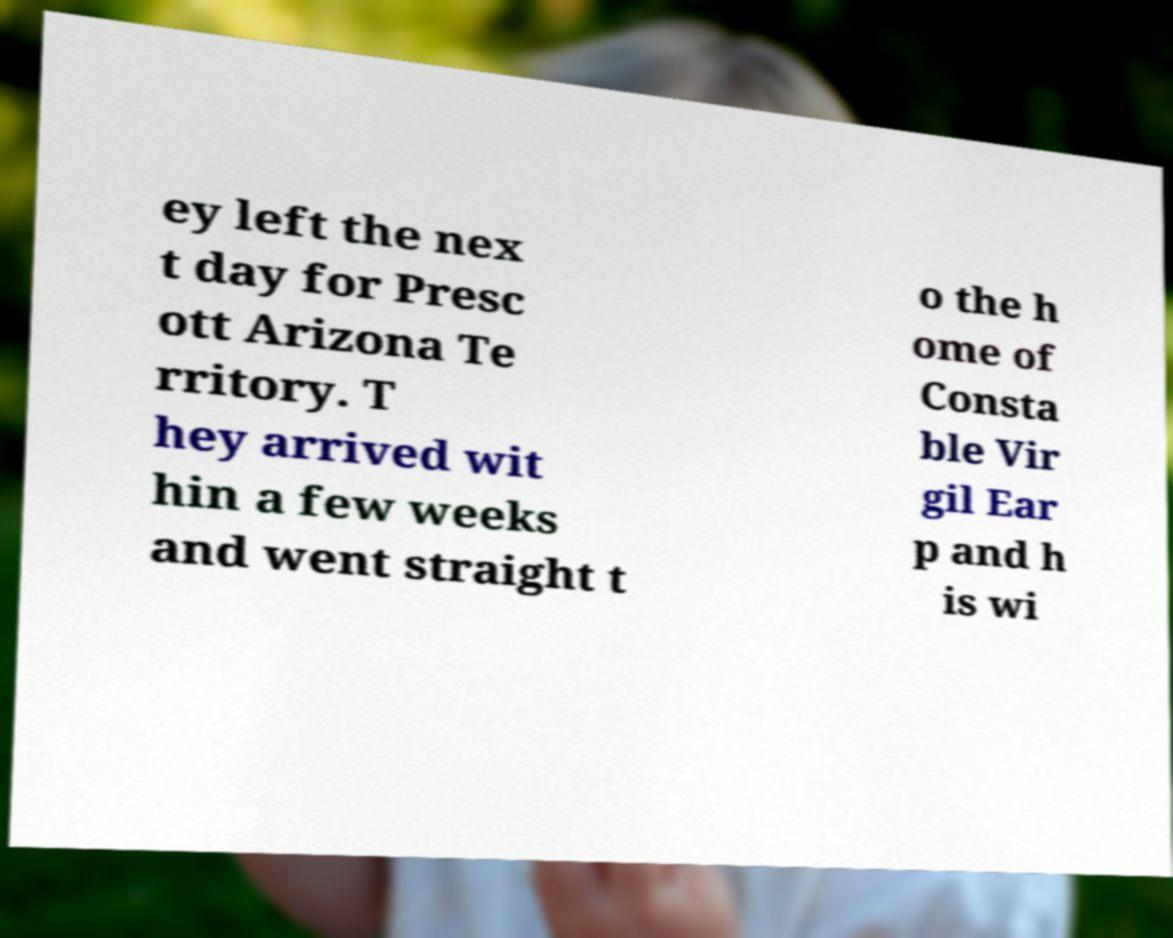Please read and relay the text visible in this image. What does it say? ey left the nex t day for Presc ott Arizona Te rritory. T hey arrived wit hin a few weeks and went straight t o the h ome of Consta ble Vir gil Ear p and h is wi 